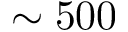Convert formula to latex. <formula><loc_0><loc_0><loc_500><loc_500>\sim 5 0 0</formula> 